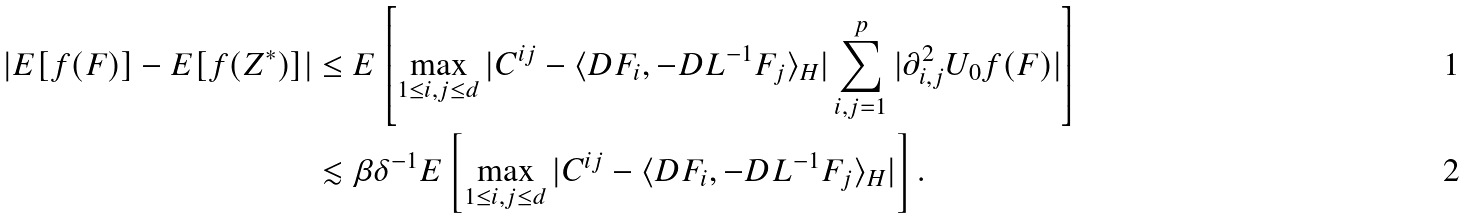<formula> <loc_0><loc_0><loc_500><loc_500>| E [ f ( F ) ] - E [ f ( Z ^ { * } ) ] | & \leq E \left [ \max _ { 1 \leq i , j \leq d } | C ^ { i j } - \langle D F _ { i } , - D L ^ { - 1 } F _ { j } \rangle _ { H } | \sum _ { i , j = 1 } ^ { p } | \partial ^ { 2 } _ { i , j } U _ { 0 } f ( F ) | \right ] \\ & \lesssim \beta \delta ^ { - 1 } E \left [ \max _ { 1 \leq i , j \leq d } | C ^ { i j } - \langle D F _ { i } , - D L ^ { - 1 } F _ { j } \rangle _ { H } | \right ] .</formula> 